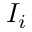Convert formula to latex. <formula><loc_0><loc_0><loc_500><loc_500>I _ { i }</formula> 